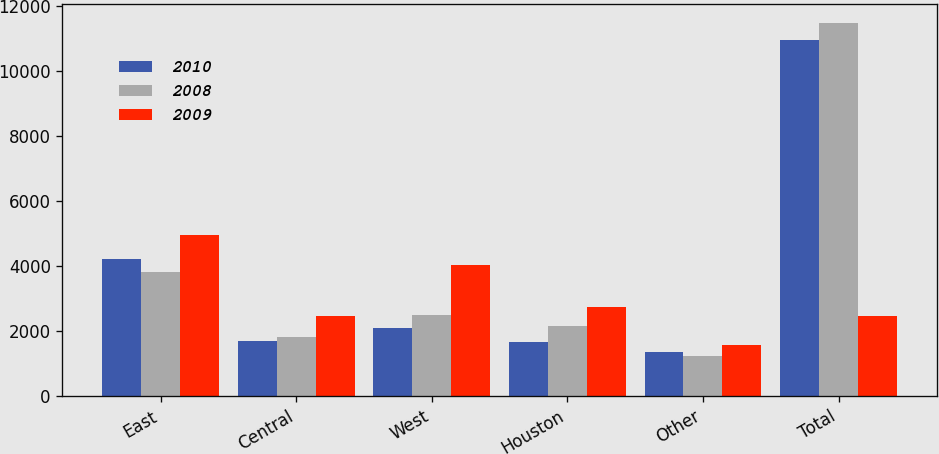<chart> <loc_0><loc_0><loc_500><loc_500><stacked_bar_chart><ecel><fcel>East<fcel>Central<fcel>West<fcel>Houston<fcel>Other<fcel>Total<nl><fcel>2010<fcel>4195<fcel>1682<fcel>2079<fcel>1645<fcel>1354<fcel>10955<nl><fcel>2008<fcel>3817<fcel>1796<fcel>2480<fcel>2150<fcel>1235<fcel>11478<nl><fcel>2009<fcel>4957<fcel>2442<fcel>4031<fcel>2736<fcel>1569<fcel>2442<nl></chart> 